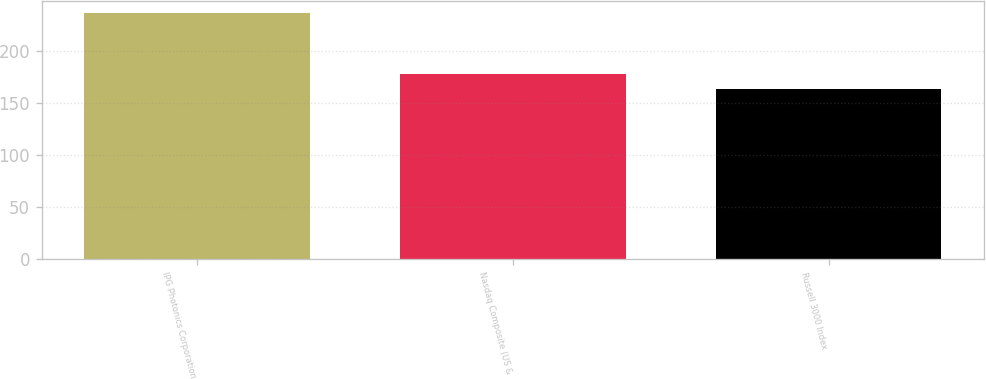Convert chart to OTSL. <chart><loc_0><loc_0><loc_500><loc_500><bar_chart><fcel>IPG Photonics Corporation<fcel>Nasdaq Composite (US &<fcel>Russell 3000 Index<nl><fcel>236.94<fcel>178.53<fcel>163.33<nl></chart> 